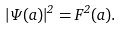<formula> <loc_0><loc_0><loc_500><loc_500>| \Psi ( a ) | ^ { 2 } = F ^ { 2 } ( a ) .</formula> 